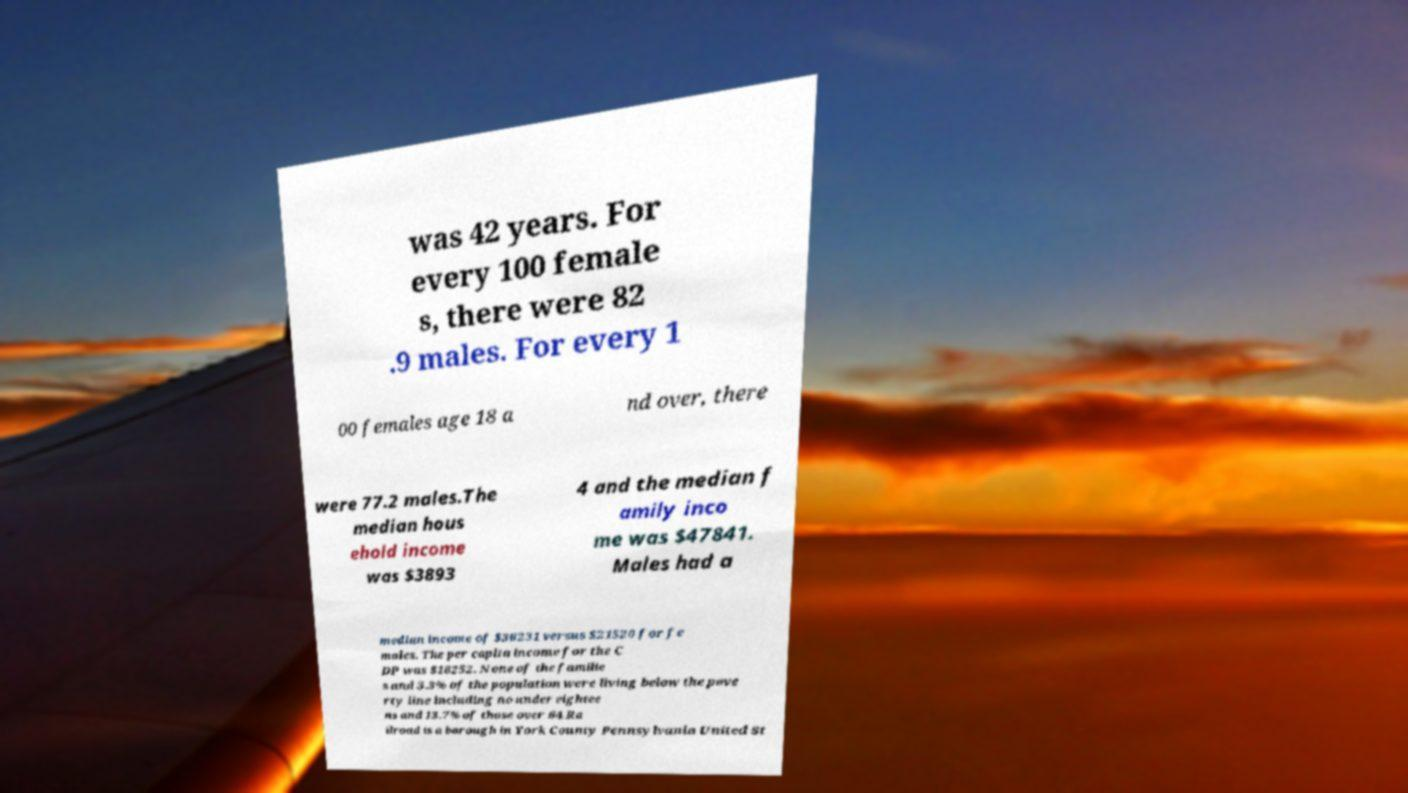Please read and relay the text visible in this image. What does it say? was 42 years. For every 100 female s, there were 82 .9 males. For every 1 00 females age 18 a nd over, there were 77.2 males.The median hous ehold income was $3893 4 and the median f amily inco me was $47841. Males had a median income of $36231 versus $21520 for fe males. The per capita income for the C DP was $18252. None of the familie s and 3.3% of the population were living below the pove rty line including no under eightee ns and 13.7% of those over 64.Ra ilroad is a borough in York County Pennsylvania United St 